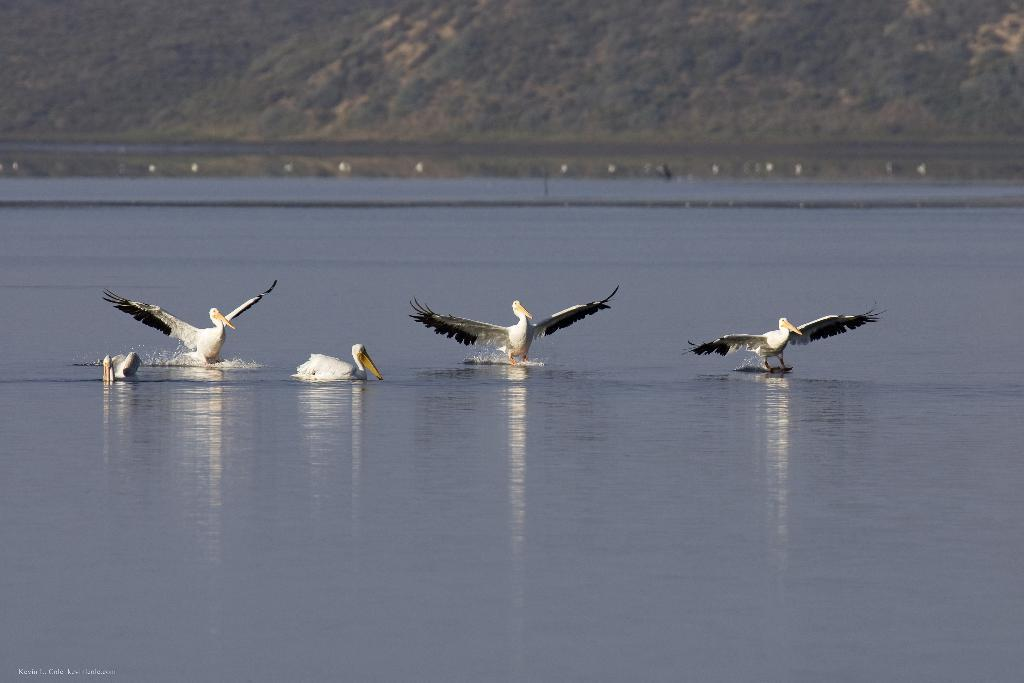What type of animals can be seen in the image? There are birds in the image. What are the birds doing in the image? The birds are swimming in the water. What can be seen in the background of the image? There is a mountain visible behind the water. What is the weight of the design on the birds' wings in the image? There is no design on the birds' wings in the image, and therefore no weight can be attributed to it. 